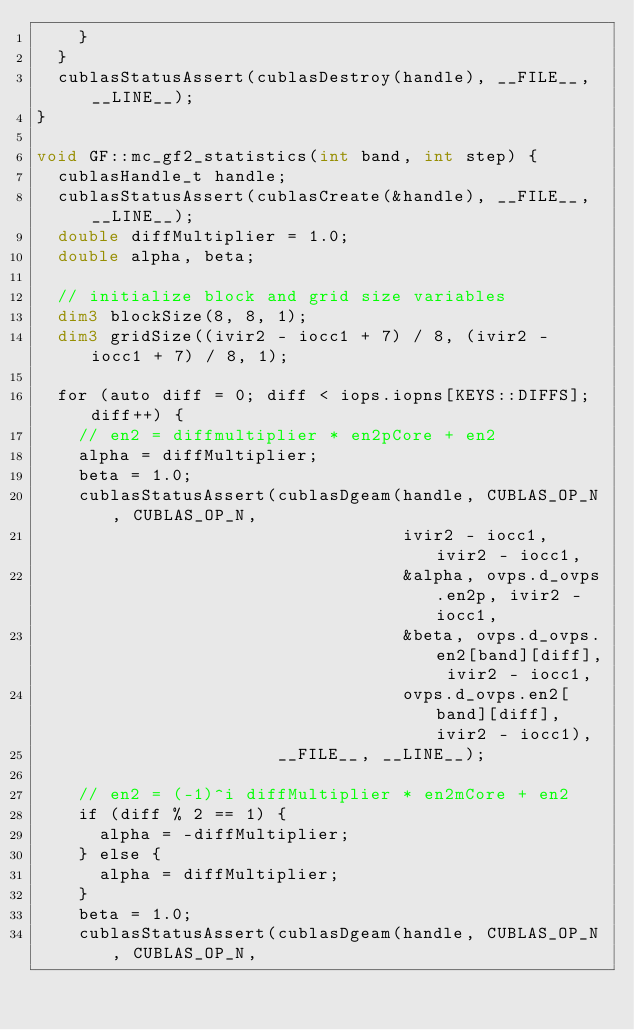Convert code to text. <code><loc_0><loc_0><loc_500><loc_500><_Cuda_>    }
  }
  cublasStatusAssert(cublasDestroy(handle), __FILE__, __LINE__);
}

void GF::mc_gf2_statistics(int band, int step) {
  cublasHandle_t handle;
  cublasStatusAssert(cublasCreate(&handle), __FILE__, __LINE__);
  double diffMultiplier = 1.0;
  double alpha, beta;

  // initialize block and grid size variables
  dim3 blockSize(8, 8, 1);
  dim3 gridSize((ivir2 - iocc1 + 7) / 8, (ivir2 - iocc1 + 7) / 8, 1);

  for (auto diff = 0; diff < iops.iopns[KEYS::DIFFS]; diff++) {
    // en2 = diffmultiplier * en2pCore + en2
    alpha = diffMultiplier;
    beta = 1.0;
    cublasStatusAssert(cublasDgeam(handle, CUBLAS_OP_N, CUBLAS_OP_N,
                                   ivir2 - iocc1, ivir2 - iocc1,
                                   &alpha, ovps.d_ovps.en2p, ivir2 - iocc1,
                                   &beta, ovps.d_ovps.en2[band][diff], ivir2 - iocc1,
                                   ovps.d_ovps.en2[band][diff], ivir2 - iocc1),
                       __FILE__, __LINE__);

    // en2 = (-1)^i diffMultiplier * en2mCore + en2
    if (diff % 2 == 1) {
      alpha = -diffMultiplier;
    } else {
      alpha = diffMultiplier;
    }
    beta = 1.0;
    cublasStatusAssert(cublasDgeam(handle, CUBLAS_OP_N, CUBLAS_OP_N,</code> 